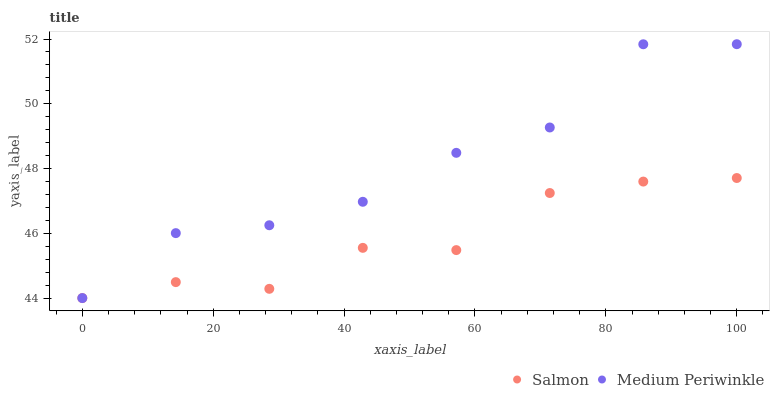Does Salmon have the minimum area under the curve?
Answer yes or no. Yes. Does Medium Periwinkle have the maximum area under the curve?
Answer yes or no. Yes. Does Salmon have the maximum area under the curve?
Answer yes or no. No. Is Salmon the smoothest?
Answer yes or no. Yes. Is Medium Periwinkle the roughest?
Answer yes or no. Yes. Is Salmon the roughest?
Answer yes or no. No. Does Medium Periwinkle have the lowest value?
Answer yes or no. Yes. Does Medium Periwinkle have the highest value?
Answer yes or no. Yes. Does Salmon have the highest value?
Answer yes or no. No. Does Salmon intersect Medium Periwinkle?
Answer yes or no. Yes. Is Salmon less than Medium Periwinkle?
Answer yes or no. No. Is Salmon greater than Medium Periwinkle?
Answer yes or no. No. 